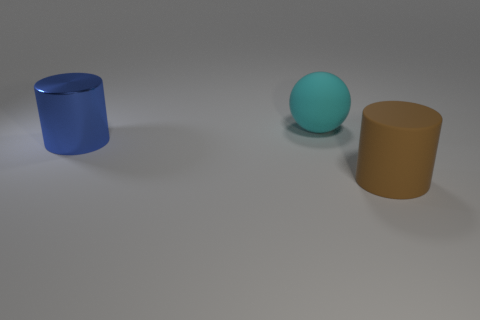Subtract all blue cylinders. How many cylinders are left? 1 Add 1 tiny green matte things. How many objects exist? 4 Subtract all balls. How many objects are left? 2 Subtract 0 gray blocks. How many objects are left? 3 Subtract 1 cylinders. How many cylinders are left? 1 Subtract all brown cylinders. Subtract all gray spheres. How many cylinders are left? 1 Subtract all purple shiny spheres. Subtract all big brown matte things. How many objects are left? 2 Add 1 blue things. How many blue things are left? 2 Add 3 big metallic objects. How many big metallic objects exist? 4 